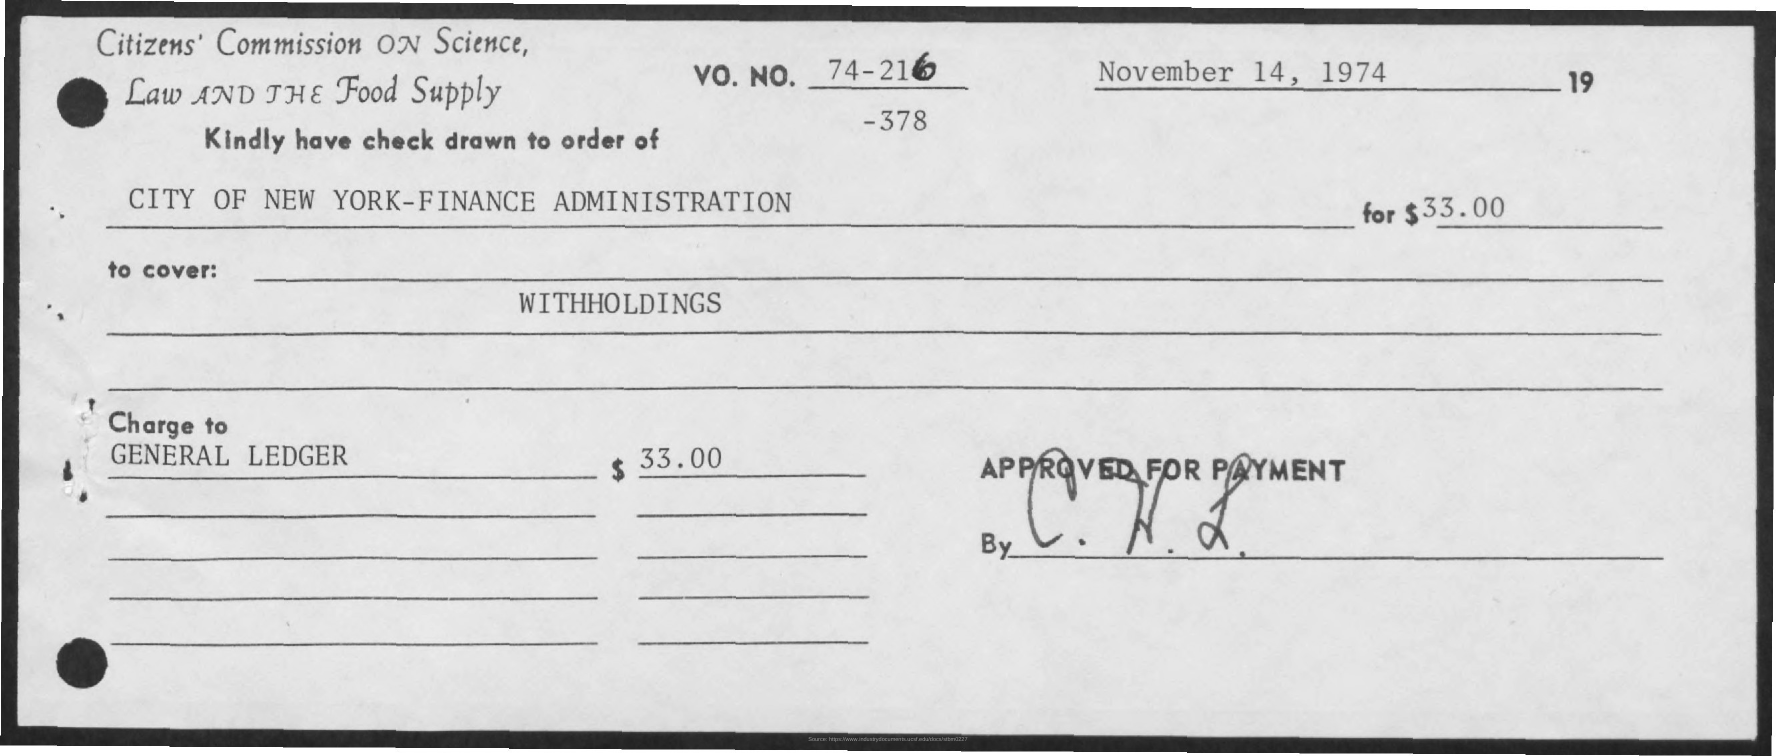Who is the drawer of the cheque?
Provide a succinct answer. CITY OF NEW YORK-FINANCE ADMINISTRATION. How many dollars were written on the cheque?
Ensure brevity in your answer.  33.00. 